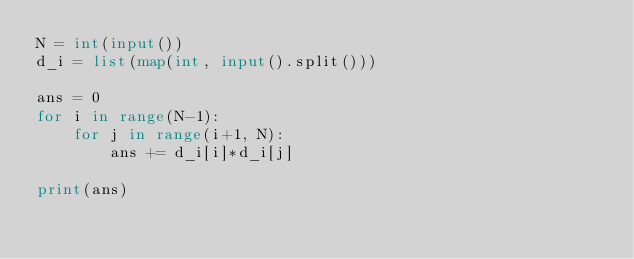Convert code to text. <code><loc_0><loc_0><loc_500><loc_500><_Python_>N = int(input())
d_i = list(map(int, input().split()))

ans = 0
for i in range(N-1):
    for j in range(i+1, N):
        ans += d_i[i]*d_i[j]

print(ans)
</code> 